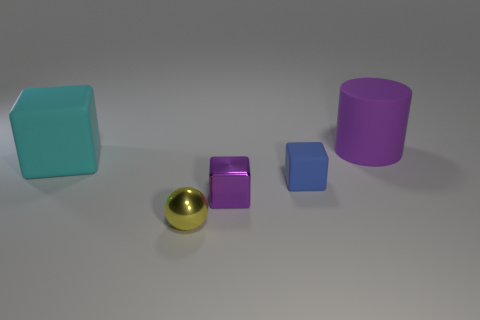Is the color of the rubber cylinder the same as the small shiny cube?
Offer a terse response. Yes. How many metallic objects are either big purple objects or purple things?
Offer a very short reply. 1. There is a purple metallic thing that is the same shape as the tiny blue thing; what size is it?
Offer a terse response. Small. Does the yellow metallic object have the same size as the metal object on the right side of the small metal ball?
Offer a terse response. Yes. There is a purple object that is on the left side of the tiny blue object; what shape is it?
Offer a very short reply. Cube. What is the color of the big matte object left of the rubber object behind the cyan rubber block?
Your answer should be compact. Cyan. The metal thing that is the same shape as the small rubber thing is what color?
Your answer should be very brief. Purple. What number of metallic objects have the same color as the big matte cylinder?
Your answer should be very brief. 1. Is the color of the large rubber cylinder the same as the block that is in front of the blue thing?
Your answer should be very brief. Yes. What is the shape of the thing that is both right of the tiny purple metallic thing and to the left of the big purple matte cylinder?
Your response must be concise. Cube. 